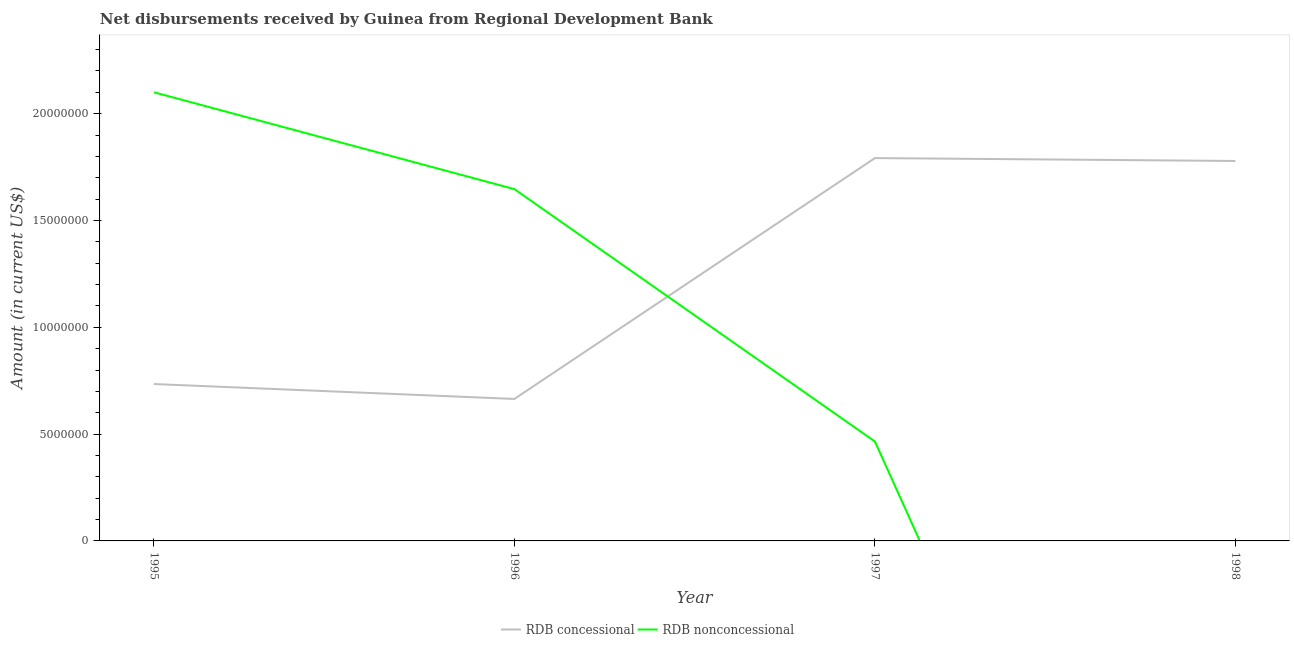How many different coloured lines are there?
Provide a short and direct response. 2. Does the line corresponding to net non concessional disbursements from rdb intersect with the line corresponding to net concessional disbursements from rdb?
Provide a succinct answer. Yes. Is the number of lines equal to the number of legend labels?
Ensure brevity in your answer.  No. What is the net concessional disbursements from rdb in 1998?
Ensure brevity in your answer.  1.78e+07. Across all years, what is the maximum net non concessional disbursements from rdb?
Your answer should be compact. 2.10e+07. Across all years, what is the minimum net non concessional disbursements from rdb?
Make the answer very short. 0. In which year was the net concessional disbursements from rdb maximum?
Offer a very short reply. 1997. What is the total net non concessional disbursements from rdb in the graph?
Make the answer very short. 4.21e+07. What is the difference between the net concessional disbursements from rdb in 1995 and that in 1998?
Give a very brief answer. -1.04e+07. What is the difference between the net non concessional disbursements from rdb in 1996 and the net concessional disbursements from rdb in 1997?
Your response must be concise. -1.45e+06. What is the average net concessional disbursements from rdb per year?
Give a very brief answer. 1.24e+07. In the year 1997, what is the difference between the net non concessional disbursements from rdb and net concessional disbursements from rdb?
Your answer should be very brief. -1.33e+07. In how many years, is the net concessional disbursements from rdb greater than 11000000 US$?
Your response must be concise. 2. What is the ratio of the net concessional disbursements from rdb in 1995 to that in 1998?
Offer a very short reply. 0.41. What is the difference between the highest and the second highest net concessional disbursements from rdb?
Provide a succinct answer. 1.35e+05. What is the difference between the highest and the lowest net non concessional disbursements from rdb?
Offer a terse response. 2.10e+07. Does the net concessional disbursements from rdb monotonically increase over the years?
Provide a succinct answer. No. Is the net concessional disbursements from rdb strictly less than the net non concessional disbursements from rdb over the years?
Provide a short and direct response. No. How many lines are there?
Keep it short and to the point. 2. How many years are there in the graph?
Keep it short and to the point. 4. What is the difference between two consecutive major ticks on the Y-axis?
Ensure brevity in your answer.  5.00e+06. Are the values on the major ticks of Y-axis written in scientific E-notation?
Provide a short and direct response. No. Where does the legend appear in the graph?
Offer a terse response. Bottom center. How many legend labels are there?
Provide a short and direct response. 2. What is the title of the graph?
Offer a terse response. Net disbursements received by Guinea from Regional Development Bank. Does "Overweight" appear as one of the legend labels in the graph?
Offer a terse response. No. What is the label or title of the X-axis?
Give a very brief answer. Year. What is the Amount (in current US$) in RDB concessional in 1995?
Provide a succinct answer. 7.34e+06. What is the Amount (in current US$) in RDB nonconcessional in 1995?
Give a very brief answer. 2.10e+07. What is the Amount (in current US$) of RDB concessional in 1996?
Keep it short and to the point. 6.65e+06. What is the Amount (in current US$) of RDB nonconcessional in 1996?
Provide a succinct answer. 1.65e+07. What is the Amount (in current US$) of RDB concessional in 1997?
Keep it short and to the point. 1.79e+07. What is the Amount (in current US$) in RDB nonconcessional in 1997?
Make the answer very short. 4.65e+06. What is the Amount (in current US$) of RDB concessional in 1998?
Your answer should be compact. 1.78e+07. What is the Amount (in current US$) in RDB nonconcessional in 1998?
Make the answer very short. 0. Across all years, what is the maximum Amount (in current US$) in RDB concessional?
Your answer should be very brief. 1.79e+07. Across all years, what is the maximum Amount (in current US$) of RDB nonconcessional?
Offer a very short reply. 2.10e+07. Across all years, what is the minimum Amount (in current US$) of RDB concessional?
Ensure brevity in your answer.  6.65e+06. What is the total Amount (in current US$) in RDB concessional in the graph?
Make the answer very short. 4.97e+07. What is the total Amount (in current US$) in RDB nonconcessional in the graph?
Give a very brief answer. 4.21e+07. What is the difference between the Amount (in current US$) of RDB concessional in 1995 and that in 1996?
Offer a terse response. 6.99e+05. What is the difference between the Amount (in current US$) of RDB nonconcessional in 1995 and that in 1996?
Keep it short and to the point. 4.54e+06. What is the difference between the Amount (in current US$) of RDB concessional in 1995 and that in 1997?
Offer a very short reply. -1.06e+07. What is the difference between the Amount (in current US$) in RDB nonconcessional in 1995 and that in 1997?
Your answer should be very brief. 1.64e+07. What is the difference between the Amount (in current US$) in RDB concessional in 1995 and that in 1998?
Offer a very short reply. -1.04e+07. What is the difference between the Amount (in current US$) of RDB concessional in 1996 and that in 1997?
Offer a terse response. -1.13e+07. What is the difference between the Amount (in current US$) in RDB nonconcessional in 1996 and that in 1997?
Provide a succinct answer. 1.18e+07. What is the difference between the Amount (in current US$) of RDB concessional in 1996 and that in 1998?
Provide a succinct answer. -1.11e+07. What is the difference between the Amount (in current US$) in RDB concessional in 1997 and that in 1998?
Keep it short and to the point. 1.35e+05. What is the difference between the Amount (in current US$) of RDB concessional in 1995 and the Amount (in current US$) of RDB nonconcessional in 1996?
Provide a short and direct response. -9.12e+06. What is the difference between the Amount (in current US$) in RDB concessional in 1995 and the Amount (in current US$) in RDB nonconcessional in 1997?
Your answer should be compact. 2.69e+06. What is the difference between the Amount (in current US$) in RDB concessional in 1996 and the Amount (in current US$) in RDB nonconcessional in 1997?
Your answer should be very brief. 1.99e+06. What is the average Amount (in current US$) of RDB concessional per year?
Provide a succinct answer. 1.24e+07. What is the average Amount (in current US$) of RDB nonconcessional per year?
Offer a very short reply. 1.05e+07. In the year 1995, what is the difference between the Amount (in current US$) of RDB concessional and Amount (in current US$) of RDB nonconcessional?
Ensure brevity in your answer.  -1.37e+07. In the year 1996, what is the difference between the Amount (in current US$) in RDB concessional and Amount (in current US$) in RDB nonconcessional?
Provide a short and direct response. -9.82e+06. In the year 1997, what is the difference between the Amount (in current US$) in RDB concessional and Amount (in current US$) in RDB nonconcessional?
Give a very brief answer. 1.33e+07. What is the ratio of the Amount (in current US$) of RDB concessional in 1995 to that in 1996?
Offer a terse response. 1.11. What is the ratio of the Amount (in current US$) in RDB nonconcessional in 1995 to that in 1996?
Give a very brief answer. 1.28. What is the ratio of the Amount (in current US$) of RDB concessional in 1995 to that in 1997?
Make the answer very short. 0.41. What is the ratio of the Amount (in current US$) in RDB nonconcessional in 1995 to that in 1997?
Give a very brief answer. 4.51. What is the ratio of the Amount (in current US$) in RDB concessional in 1995 to that in 1998?
Your answer should be very brief. 0.41. What is the ratio of the Amount (in current US$) of RDB concessional in 1996 to that in 1997?
Offer a very short reply. 0.37. What is the ratio of the Amount (in current US$) of RDB nonconcessional in 1996 to that in 1997?
Make the answer very short. 3.54. What is the ratio of the Amount (in current US$) in RDB concessional in 1996 to that in 1998?
Ensure brevity in your answer.  0.37. What is the ratio of the Amount (in current US$) in RDB concessional in 1997 to that in 1998?
Offer a terse response. 1.01. What is the difference between the highest and the second highest Amount (in current US$) in RDB concessional?
Your response must be concise. 1.35e+05. What is the difference between the highest and the second highest Amount (in current US$) in RDB nonconcessional?
Your answer should be very brief. 4.54e+06. What is the difference between the highest and the lowest Amount (in current US$) in RDB concessional?
Offer a terse response. 1.13e+07. What is the difference between the highest and the lowest Amount (in current US$) in RDB nonconcessional?
Provide a succinct answer. 2.10e+07. 